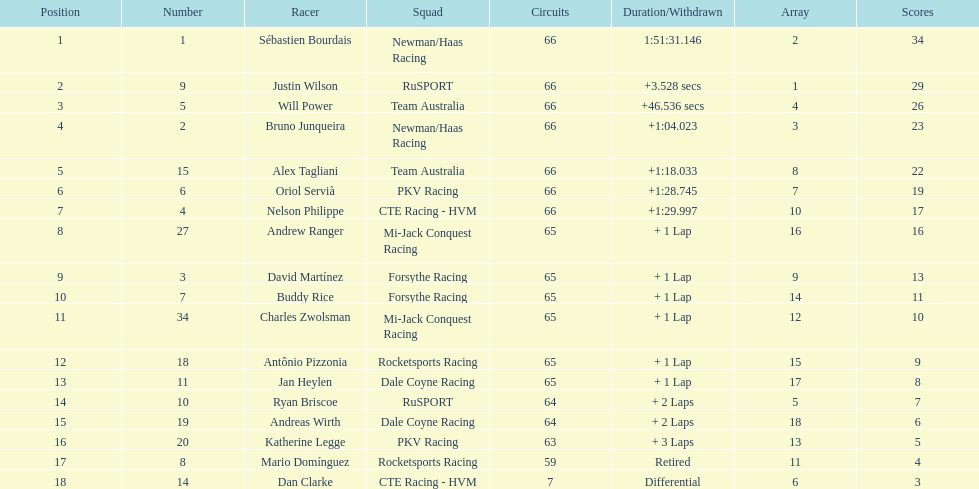Who earned the most points at the 2006 gran premio telmex? Sébastien Bourdais. 